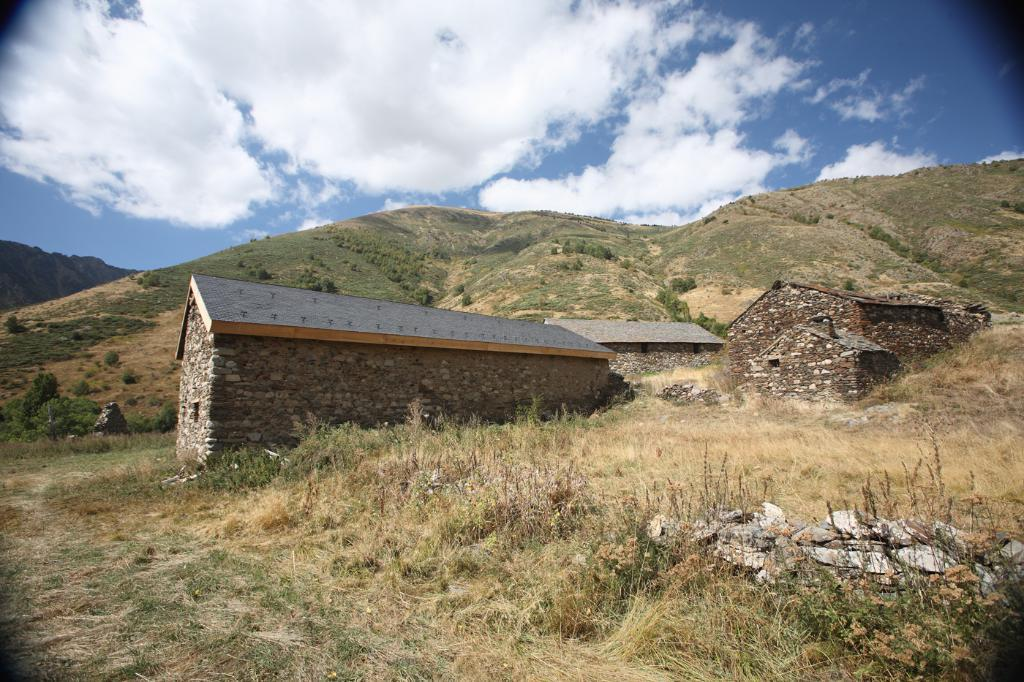What type of structures can be seen in the image? There are houses in the image. What material was used to build the walls of the houses? The walls of the houses are built with stones. What can be seen in the distance behind the houses? There are mountains in the background of the image. How would you describe the weather in the image? The sky is sunny in the background of the image, suggesting a clear and sunny day. Can you tell me who is giving the tramp a haircut in the image? There is no tramp or haircut depicted in the image; it features houses with stone walls and mountains in the background. 